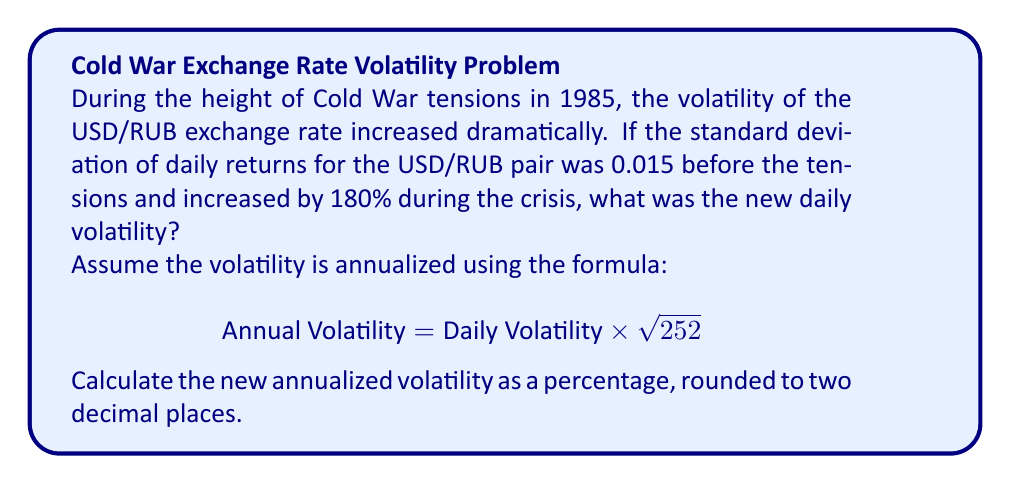Solve this math problem. Let's approach this step-by-step:

1) First, we need to calculate the new daily volatility:
   - Original daily volatility = 0.015
   - Increase = 180% = 1.8 times
   - New daily volatility = $0.015 \times (1 + 1.8) = 0.015 \times 2.8 = 0.042$

2) Now, we need to annualize this volatility:
   - We use the formula: $\text{Annual Volatility} = \text{Daily Volatility} \times \sqrt{252}$
   - Here, 252 is the typical number of trading days in a year

3) Let's calculate:
   $$\text{Annual Volatility} = 0.042 \times \sqrt{252} = 0.042 \times 15.8745 = 0.6667$$

4) Convert to percentage:
   $0.6667 \times 100 = 66.67\%$

5) Rounding to two decimal places:
   $66.67\%$

This significant increase in volatility reflects the heightened uncertainty and risk in the currency market during periods of geopolitical tension, a situation that would have been of great interest to a KGB officer monitoring economic indicators.
Answer: 66.67% 